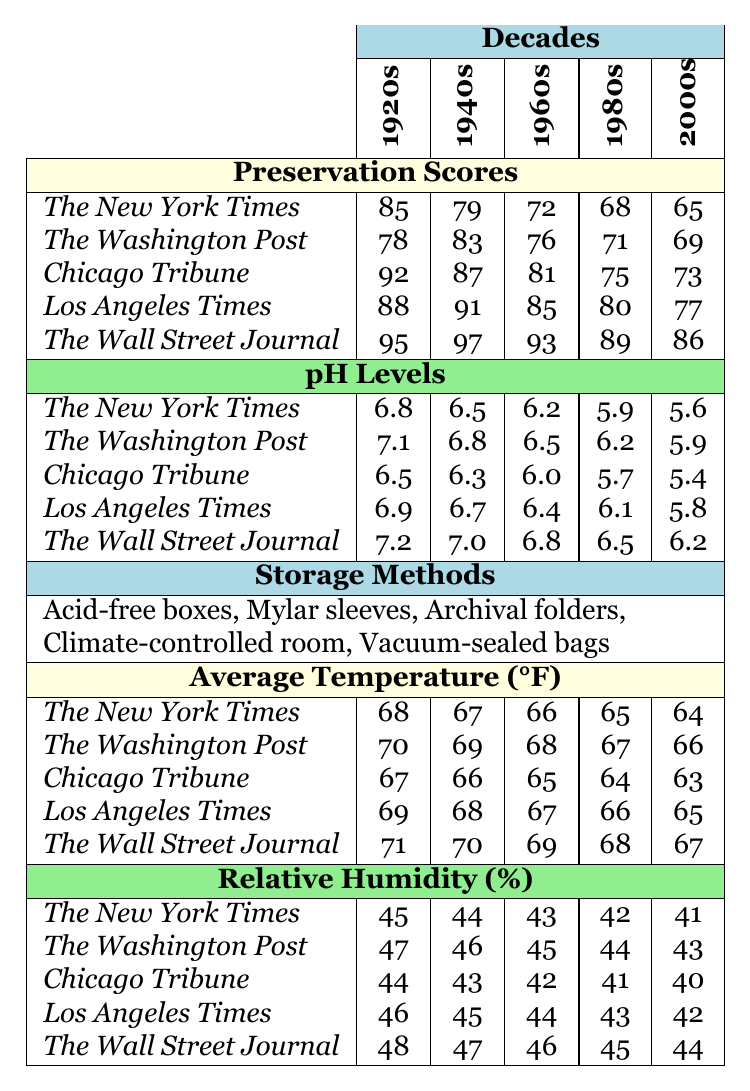What is the preservation score of the Chicago Tribune in the 1960s? The preservation scores for the Chicago Tribune in the 1960s is listed in the table as 81.
Answer: 81 Which newspaper has the highest preservation score in the 1980s? The table shows that The Wall Street Journal has the highest preservation score in the 1980s, which is 89.
Answer: The Wall Street Journal What is the average relative humidity for the Los Angeles Times across all decades? To find the average, sum the relative humidity values for the Los Angeles Times (46 + 45 + 44 + 43 + 42 = 220) and divide by the number of decades (5), resulting in 220/5 = 44.
Answer: 44 Is the pH level of The Wall Street Journal increasing or decreasing from the 1920s to the 2000s? In the table, the pH level for The Wall Street Journal shows values of 7.2 (1920s), 7.0 (1940s), 6.8 (1960s), 6.5 (1980s), and 6.2 (2000s), which indicates a decreasing trend over the decades.
Answer: Decreasing Which decade shows the lowest average temperature for The New York Times? The temperatures for The New York Times are 68 (1920s), 67 (1940s), 66 (1960s), 65 (1980s), and 64 (2000s). The lowest value is 64, which is in the 2000s.
Answer: 2000s How does the preservation score of the 1940s compare to the 2000s for The Washington Post? For The Washington Post, the preservation score in the 1940s is 83, while in the 2000s it is 69. The difference is 83 - 69 = 14, indicating the score decreased by 14 points.
Answer: Decreased by 14 points What is the range of preservation scores across all decades for the Chicago Tribune? The preservation scores for the Chicago Tribune are 92 (1920s), 87 (1940s), 81 (1960s), 75 (1980s), and 73 (2000s). The highest score is 92 and the lowest is 73. The range is calculated as 92 - 73 = 19.
Answer: 19 Which storage method is used for newspapers from all decades in this collection? The storage methods listed in the table include "Acid-free boxes," "Mylar sleeves," "Archival folders," "Climate-controlled room," and "Vacuum-sealed bags." All listed methods are used across all decades.
Answer: All listed methods In which decade does the pH level of The New York Times first drop below 7.0? The pH levels for The New York Times are 6.8 (1920s), 7.1 (1940s), 6.5 (1960s), 5.9 (1980s), and 5.6 (2000s). It first drops below 7.0 in the 1960s.
Answer: 1960s What can be inferred about the storage conditions from the average temperature and relative humidity for The Wall Street Journal in the 1980s? In the 1980s, The Wall Street Journal had an average temperature of 68°F and a relative humidity of 45%. These conditions are generally considered good for preserving papers, as moderate temperature and humidity can help reduce degradation.
Answer: Good preservation conditions 